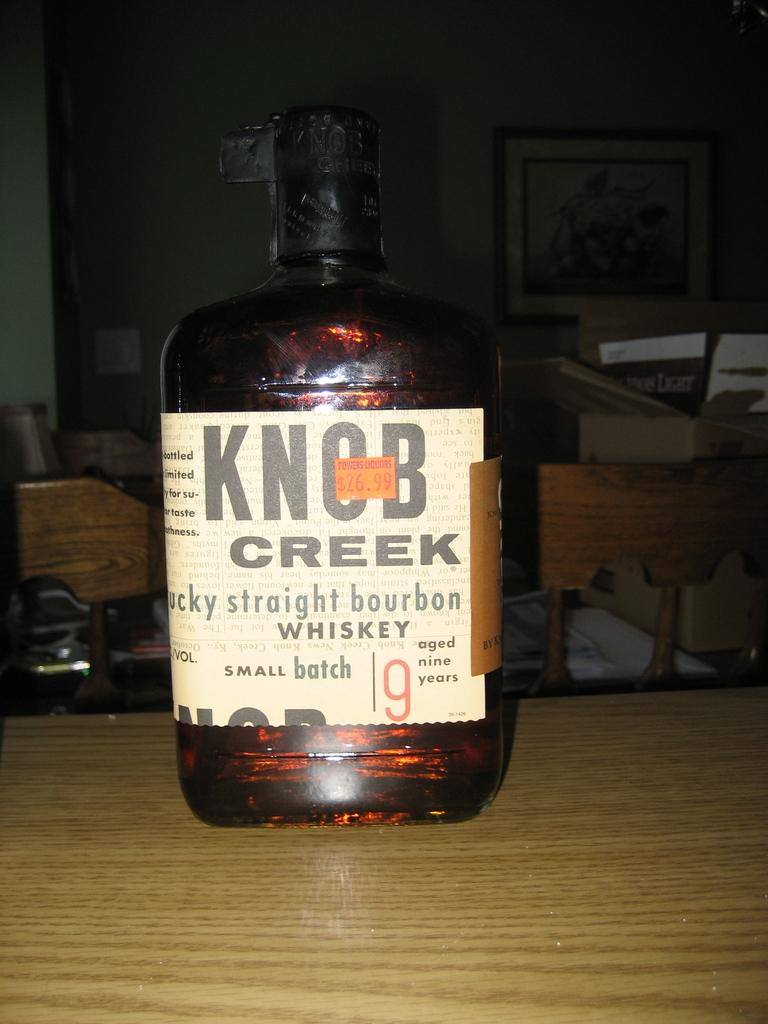<image>
Summarize the visual content of the image. Knob Creek Whiskey is $26.99 at Powers Liquors. 